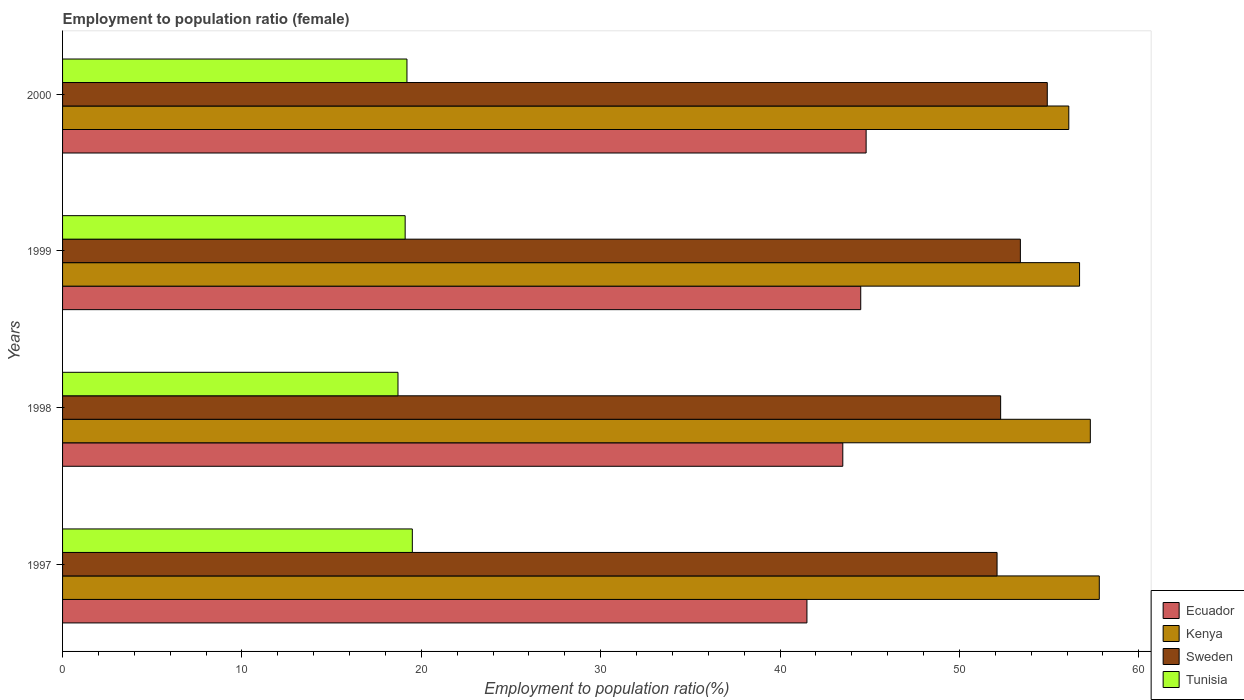How many different coloured bars are there?
Offer a very short reply. 4. Are the number of bars per tick equal to the number of legend labels?
Make the answer very short. Yes. Are the number of bars on each tick of the Y-axis equal?
Provide a succinct answer. Yes. How many bars are there on the 1st tick from the top?
Keep it short and to the point. 4. Across all years, what is the maximum employment to population ratio in Kenya?
Make the answer very short. 57.8. Across all years, what is the minimum employment to population ratio in Sweden?
Provide a short and direct response. 52.1. In which year was the employment to population ratio in Sweden maximum?
Your answer should be compact. 2000. In which year was the employment to population ratio in Kenya minimum?
Keep it short and to the point. 2000. What is the total employment to population ratio in Ecuador in the graph?
Provide a succinct answer. 174.3. What is the difference between the employment to population ratio in Tunisia in 1998 and that in 1999?
Your answer should be compact. -0.4. What is the difference between the employment to population ratio in Kenya in 2000 and the employment to population ratio in Ecuador in 1999?
Make the answer very short. 11.6. What is the average employment to population ratio in Sweden per year?
Provide a succinct answer. 53.18. In the year 1998, what is the difference between the employment to population ratio in Kenya and employment to population ratio in Ecuador?
Your response must be concise. 13.8. In how many years, is the employment to population ratio in Kenya greater than 54 %?
Offer a very short reply. 4. What is the ratio of the employment to population ratio in Sweden in 1997 to that in 1999?
Provide a succinct answer. 0.98. What is the difference between the highest and the lowest employment to population ratio in Tunisia?
Make the answer very short. 0.8. In how many years, is the employment to population ratio in Tunisia greater than the average employment to population ratio in Tunisia taken over all years?
Ensure brevity in your answer.  2. Is the sum of the employment to population ratio in Ecuador in 1997 and 2000 greater than the maximum employment to population ratio in Sweden across all years?
Provide a short and direct response. Yes. What does the 3rd bar from the top in 1997 represents?
Make the answer very short. Kenya. What does the 1st bar from the bottom in 1999 represents?
Make the answer very short. Ecuador. How many bars are there?
Keep it short and to the point. 16. What is the difference between two consecutive major ticks on the X-axis?
Your answer should be very brief. 10. Are the values on the major ticks of X-axis written in scientific E-notation?
Offer a very short reply. No. Does the graph contain any zero values?
Offer a very short reply. No. Where does the legend appear in the graph?
Your answer should be compact. Bottom right. What is the title of the graph?
Your answer should be compact. Employment to population ratio (female). What is the label or title of the X-axis?
Ensure brevity in your answer.  Employment to population ratio(%). What is the label or title of the Y-axis?
Make the answer very short. Years. What is the Employment to population ratio(%) in Ecuador in 1997?
Your response must be concise. 41.5. What is the Employment to population ratio(%) of Kenya in 1997?
Your answer should be compact. 57.8. What is the Employment to population ratio(%) in Sweden in 1997?
Keep it short and to the point. 52.1. What is the Employment to population ratio(%) in Tunisia in 1997?
Ensure brevity in your answer.  19.5. What is the Employment to population ratio(%) of Ecuador in 1998?
Make the answer very short. 43.5. What is the Employment to population ratio(%) in Kenya in 1998?
Your answer should be very brief. 57.3. What is the Employment to population ratio(%) in Sweden in 1998?
Provide a succinct answer. 52.3. What is the Employment to population ratio(%) of Tunisia in 1998?
Your answer should be compact. 18.7. What is the Employment to population ratio(%) in Ecuador in 1999?
Keep it short and to the point. 44.5. What is the Employment to population ratio(%) of Kenya in 1999?
Provide a short and direct response. 56.7. What is the Employment to population ratio(%) of Sweden in 1999?
Give a very brief answer. 53.4. What is the Employment to population ratio(%) of Tunisia in 1999?
Make the answer very short. 19.1. What is the Employment to population ratio(%) of Ecuador in 2000?
Ensure brevity in your answer.  44.8. What is the Employment to population ratio(%) in Kenya in 2000?
Your answer should be very brief. 56.1. What is the Employment to population ratio(%) of Sweden in 2000?
Ensure brevity in your answer.  54.9. What is the Employment to population ratio(%) of Tunisia in 2000?
Make the answer very short. 19.2. Across all years, what is the maximum Employment to population ratio(%) of Ecuador?
Your answer should be compact. 44.8. Across all years, what is the maximum Employment to population ratio(%) of Kenya?
Give a very brief answer. 57.8. Across all years, what is the maximum Employment to population ratio(%) in Sweden?
Provide a short and direct response. 54.9. Across all years, what is the minimum Employment to population ratio(%) of Ecuador?
Your response must be concise. 41.5. Across all years, what is the minimum Employment to population ratio(%) in Kenya?
Your answer should be compact. 56.1. Across all years, what is the minimum Employment to population ratio(%) of Sweden?
Provide a succinct answer. 52.1. Across all years, what is the minimum Employment to population ratio(%) in Tunisia?
Offer a terse response. 18.7. What is the total Employment to population ratio(%) of Ecuador in the graph?
Offer a very short reply. 174.3. What is the total Employment to population ratio(%) of Kenya in the graph?
Your answer should be compact. 227.9. What is the total Employment to population ratio(%) in Sweden in the graph?
Give a very brief answer. 212.7. What is the total Employment to population ratio(%) in Tunisia in the graph?
Your response must be concise. 76.5. What is the difference between the Employment to population ratio(%) of Kenya in 1997 and that in 1998?
Make the answer very short. 0.5. What is the difference between the Employment to population ratio(%) of Sweden in 1997 and that in 1998?
Give a very brief answer. -0.2. What is the difference between the Employment to population ratio(%) of Tunisia in 1997 and that in 1998?
Your answer should be compact. 0.8. What is the difference between the Employment to population ratio(%) of Ecuador in 1997 and that in 1999?
Provide a succinct answer. -3. What is the difference between the Employment to population ratio(%) of Sweden in 1997 and that in 1999?
Provide a short and direct response. -1.3. What is the difference between the Employment to population ratio(%) of Kenya in 1997 and that in 2000?
Your response must be concise. 1.7. What is the difference between the Employment to population ratio(%) in Tunisia in 1997 and that in 2000?
Ensure brevity in your answer.  0.3. What is the difference between the Employment to population ratio(%) in Ecuador in 1998 and that in 1999?
Provide a succinct answer. -1. What is the difference between the Employment to population ratio(%) of Kenya in 1998 and that in 2000?
Your answer should be very brief. 1.2. What is the difference between the Employment to population ratio(%) in Tunisia in 1998 and that in 2000?
Keep it short and to the point. -0.5. What is the difference between the Employment to population ratio(%) in Sweden in 1999 and that in 2000?
Offer a very short reply. -1.5. What is the difference between the Employment to population ratio(%) in Tunisia in 1999 and that in 2000?
Offer a very short reply. -0.1. What is the difference between the Employment to population ratio(%) in Ecuador in 1997 and the Employment to population ratio(%) in Kenya in 1998?
Provide a succinct answer. -15.8. What is the difference between the Employment to population ratio(%) in Ecuador in 1997 and the Employment to population ratio(%) in Tunisia in 1998?
Provide a succinct answer. 22.8. What is the difference between the Employment to population ratio(%) in Kenya in 1997 and the Employment to population ratio(%) in Tunisia in 1998?
Make the answer very short. 39.1. What is the difference between the Employment to population ratio(%) in Sweden in 1997 and the Employment to population ratio(%) in Tunisia in 1998?
Provide a short and direct response. 33.4. What is the difference between the Employment to population ratio(%) in Ecuador in 1997 and the Employment to population ratio(%) in Kenya in 1999?
Provide a short and direct response. -15.2. What is the difference between the Employment to population ratio(%) in Ecuador in 1997 and the Employment to population ratio(%) in Sweden in 1999?
Give a very brief answer. -11.9. What is the difference between the Employment to population ratio(%) in Ecuador in 1997 and the Employment to population ratio(%) in Tunisia in 1999?
Keep it short and to the point. 22.4. What is the difference between the Employment to population ratio(%) of Kenya in 1997 and the Employment to population ratio(%) of Sweden in 1999?
Your answer should be compact. 4.4. What is the difference between the Employment to population ratio(%) in Kenya in 1997 and the Employment to population ratio(%) in Tunisia in 1999?
Your answer should be compact. 38.7. What is the difference between the Employment to population ratio(%) of Ecuador in 1997 and the Employment to population ratio(%) of Kenya in 2000?
Your answer should be very brief. -14.6. What is the difference between the Employment to population ratio(%) in Ecuador in 1997 and the Employment to population ratio(%) in Sweden in 2000?
Offer a very short reply. -13.4. What is the difference between the Employment to population ratio(%) in Ecuador in 1997 and the Employment to population ratio(%) in Tunisia in 2000?
Ensure brevity in your answer.  22.3. What is the difference between the Employment to population ratio(%) in Kenya in 1997 and the Employment to population ratio(%) in Sweden in 2000?
Offer a terse response. 2.9. What is the difference between the Employment to population ratio(%) of Kenya in 1997 and the Employment to population ratio(%) of Tunisia in 2000?
Keep it short and to the point. 38.6. What is the difference between the Employment to population ratio(%) in Sweden in 1997 and the Employment to population ratio(%) in Tunisia in 2000?
Provide a short and direct response. 32.9. What is the difference between the Employment to population ratio(%) of Ecuador in 1998 and the Employment to population ratio(%) of Kenya in 1999?
Your answer should be compact. -13.2. What is the difference between the Employment to population ratio(%) in Ecuador in 1998 and the Employment to population ratio(%) in Sweden in 1999?
Your response must be concise. -9.9. What is the difference between the Employment to population ratio(%) of Ecuador in 1998 and the Employment to population ratio(%) of Tunisia in 1999?
Provide a short and direct response. 24.4. What is the difference between the Employment to population ratio(%) of Kenya in 1998 and the Employment to population ratio(%) of Sweden in 1999?
Provide a succinct answer. 3.9. What is the difference between the Employment to population ratio(%) of Kenya in 1998 and the Employment to population ratio(%) of Tunisia in 1999?
Provide a short and direct response. 38.2. What is the difference between the Employment to population ratio(%) of Sweden in 1998 and the Employment to population ratio(%) of Tunisia in 1999?
Provide a short and direct response. 33.2. What is the difference between the Employment to population ratio(%) of Ecuador in 1998 and the Employment to population ratio(%) of Kenya in 2000?
Ensure brevity in your answer.  -12.6. What is the difference between the Employment to population ratio(%) in Ecuador in 1998 and the Employment to population ratio(%) in Tunisia in 2000?
Your answer should be compact. 24.3. What is the difference between the Employment to population ratio(%) in Kenya in 1998 and the Employment to population ratio(%) in Tunisia in 2000?
Give a very brief answer. 38.1. What is the difference between the Employment to population ratio(%) of Sweden in 1998 and the Employment to population ratio(%) of Tunisia in 2000?
Offer a very short reply. 33.1. What is the difference between the Employment to population ratio(%) in Ecuador in 1999 and the Employment to population ratio(%) in Kenya in 2000?
Your answer should be compact. -11.6. What is the difference between the Employment to population ratio(%) in Ecuador in 1999 and the Employment to population ratio(%) in Tunisia in 2000?
Give a very brief answer. 25.3. What is the difference between the Employment to population ratio(%) of Kenya in 1999 and the Employment to population ratio(%) of Sweden in 2000?
Provide a short and direct response. 1.8. What is the difference between the Employment to population ratio(%) in Kenya in 1999 and the Employment to population ratio(%) in Tunisia in 2000?
Your answer should be very brief. 37.5. What is the difference between the Employment to population ratio(%) in Sweden in 1999 and the Employment to population ratio(%) in Tunisia in 2000?
Keep it short and to the point. 34.2. What is the average Employment to population ratio(%) in Ecuador per year?
Ensure brevity in your answer.  43.58. What is the average Employment to population ratio(%) of Kenya per year?
Offer a very short reply. 56.98. What is the average Employment to population ratio(%) in Sweden per year?
Provide a succinct answer. 53.17. What is the average Employment to population ratio(%) of Tunisia per year?
Your answer should be compact. 19.12. In the year 1997, what is the difference between the Employment to population ratio(%) of Ecuador and Employment to population ratio(%) of Kenya?
Ensure brevity in your answer.  -16.3. In the year 1997, what is the difference between the Employment to population ratio(%) in Ecuador and Employment to population ratio(%) in Sweden?
Offer a very short reply. -10.6. In the year 1997, what is the difference between the Employment to population ratio(%) of Ecuador and Employment to population ratio(%) of Tunisia?
Your response must be concise. 22. In the year 1997, what is the difference between the Employment to population ratio(%) of Kenya and Employment to population ratio(%) of Sweden?
Your response must be concise. 5.7. In the year 1997, what is the difference between the Employment to population ratio(%) in Kenya and Employment to population ratio(%) in Tunisia?
Provide a short and direct response. 38.3. In the year 1997, what is the difference between the Employment to population ratio(%) of Sweden and Employment to population ratio(%) of Tunisia?
Your answer should be compact. 32.6. In the year 1998, what is the difference between the Employment to population ratio(%) of Ecuador and Employment to population ratio(%) of Kenya?
Your answer should be compact. -13.8. In the year 1998, what is the difference between the Employment to population ratio(%) in Ecuador and Employment to population ratio(%) in Sweden?
Your answer should be compact. -8.8. In the year 1998, what is the difference between the Employment to population ratio(%) of Ecuador and Employment to population ratio(%) of Tunisia?
Keep it short and to the point. 24.8. In the year 1998, what is the difference between the Employment to population ratio(%) in Kenya and Employment to population ratio(%) in Sweden?
Provide a short and direct response. 5. In the year 1998, what is the difference between the Employment to population ratio(%) in Kenya and Employment to population ratio(%) in Tunisia?
Ensure brevity in your answer.  38.6. In the year 1998, what is the difference between the Employment to population ratio(%) of Sweden and Employment to population ratio(%) of Tunisia?
Provide a succinct answer. 33.6. In the year 1999, what is the difference between the Employment to population ratio(%) in Ecuador and Employment to population ratio(%) in Kenya?
Keep it short and to the point. -12.2. In the year 1999, what is the difference between the Employment to population ratio(%) of Ecuador and Employment to population ratio(%) of Tunisia?
Provide a succinct answer. 25.4. In the year 1999, what is the difference between the Employment to population ratio(%) in Kenya and Employment to population ratio(%) in Sweden?
Provide a succinct answer. 3.3. In the year 1999, what is the difference between the Employment to population ratio(%) in Kenya and Employment to population ratio(%) in Tunisia?
Your response must be concise. 37.6. In the year 1999, what is the difference between the Employment to population ratio(%) of Sweden and Employment to population ratio(%) of Tunisia?
Provide a short and direct response. 34.3. In the year 2000, what is the difference between the Employment to population ratio(%) of Ecuador and Employment to population ratio(%) of Kenya?
Your answer should be compact. -11.3. In the year 2000, what is the difference between the Employment to population ratio(%) of Ecuador and Employment to population ratio(%) of Sweden?
Your answer should be compact. -10.1. In the year 2000, what is the difference between the Employment to population ratio(%) of Ecuador and Employment to population ratio(%) of Tunisia?
Your response must be concise. 25.6. In the year 2000, what is the difference between the Employment to population ratio(%) in Kenya and Employment to population ratio(%) in Sweden?
Provide a short and direct response. 1.2. In the year 2000, what is the difference between the Employment to population ratio(%) in Kenya and Employment to population ratio(%) in Tunisia?
Provide a short and direct response. 36.9. In the year 2000, what is the difference between the Employment to population ratio(%) of Sweden and Employment to population ratio(%) of Tunisia?
Provide a short and direct response. 35.7. What is the ratio of the Employment to population ratio(%) of Ecuador in 1997 to that in 1998?
Your answer should be compact. 0.95. What is the ratio of the Employment to population ratio(%) in Kenya in 1997 to that in 1998?
Your answer should be very brief. 1.01. What is the ratio of the Employment to population ratio(%) of Tunisia in 1997 to that in 1998?
Keep it short and to the point. 1.04. What is the ratio of the Employment to population ratio(%) of Ecuador in 1997 to that in 1999?
Offer a terse response. 0.93. What is the ratio of the Employment to population ratio(%) of Kenya in 1997 to that in 1999?
Keep it short and to the point. 1.02. What is the ratio of the Employment to population ratio(%) of Sweden in 1997 to that in 1999?
Offer a terse response. 0.98. What is the ratio of the Employment to population ratio(%) in Tunisia in 1997 to that in 1999?
Your answer should be compact. 1.02. What is the ratio of the Employment to population ratio(%) in Ecuador in 1997 to that in 2000?
Your answer should be very brief. 0.93. What is the ratio of the Employment to population ratio(%) in Kenya in 1997 to that in 2000?
Your response must be concise. 1.03. What is the ratio of the Employment to population ratio(%) of Sweden in 1997 to that in 2000?
Keep it short and to the point. 0.95. What is the ratio of the Employment to population ratio(%) in Tunisia in 1997 to that in 2000?
Provide a succinct answer. 1.02. What is the ratio of the Employment to population ratio(%) in Ecuador in 1998 to that in 1999?
Your answer should be very brief. 0.98. What is the ratio of the Employment to population ratio(%) of Kenya in 1998 to that in 1999?
Provide a short and direct response. 1.01. What is the ratio of the Employment to population ratio(%) of Sweden in 1998 to that in 1999?
Give a very brief answer. 0.98. What is the ratio of the Employment to population ratio(%) of Tunisia in 1998 to that in 1999?
Provide a succinct answer. 0.98. What is the ratio of the Employment to population ratio(%) in Kenya in 1998 to that in 2000?
Make the answer very short. 1.02. What is the ratio of the Employment to population ratio(%) in Sweden in 1998 to that in 2000?
Your answer should be compact. 0.95. What is the ratio of the Employment to population ratio(%) of Tunisia in 1998 to that in 2000?
Give a very brief answer. 0.97. What is the ratio of the Employment to population ratio(%) in Ecuador in 1999 to that in 2000?
Keep it short and to the point. 0.99. What is the ratio of the Employment to population ratio(%) in Kenya in 1999 to that in 2000?
Your answer should be very brief. 1.01. What is the ratio of the Employment to population ratio(%) in Sweden in 1999 to that in 2000?
Your response must be concise. 0.97. What is the ratio of the Employment to population ratio(%) in Tunisia in 1999 to that in 2000?
Your response must be concise. 0.99. What is the difference between the highest and the second highest Employment to population ratio(%) in Tunisia?
Ensure brevity in your answer.  0.3. What is the difference between the highest and the lowest Employment to population ratio(%) in Kenya?
Offer a terse response. 1.7. What is the difference between the highest and the lowest Employment to population ratio(%) of Tunisia?
Provide a short and direct response. 0.8. 